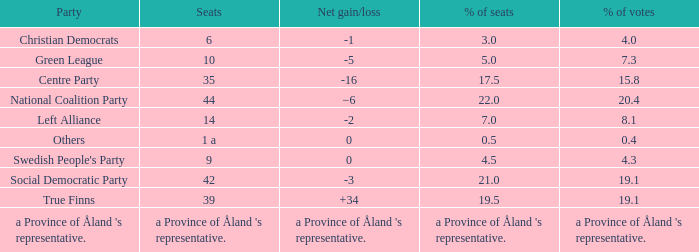Regarding the seats that casted 8.1% of the vote how many seats were held? 14.0. 